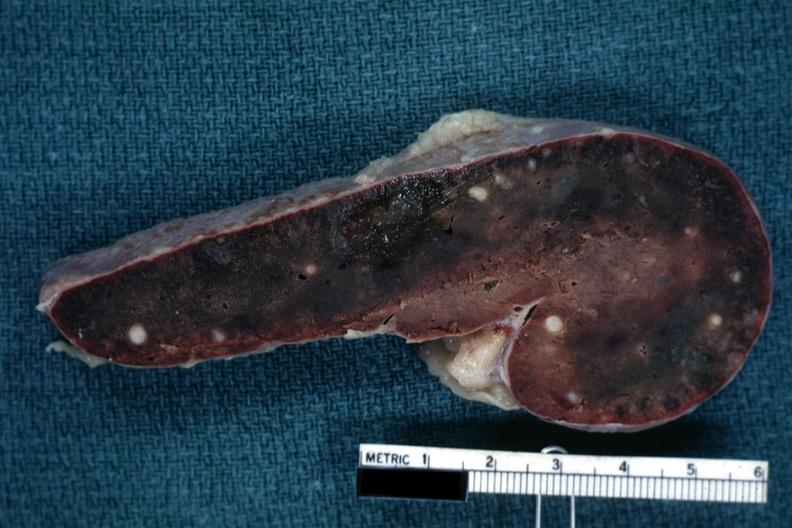does this image show fixed tissue cut surface congested parenchyma with obvious granulomas?
Answer the question using a single word or phrase. Yes 